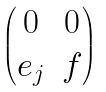Convert formula to latex. <formula><loc_0><loc_0><loc_500><loc_500>\begin{pmatrix} 0 & 0 \\ e _ { j } & f \end{pmatrix}</formula> 